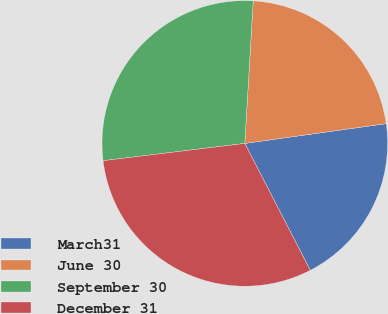Convert chart to OTSL. <chart><loc_0><loc_0><loc_500><loc_500><pie_chart><fcel>March31<fcel>June 30<fcel>September 30<fcel>December 31<nl><fcel>19.63%<fcel>21.85%<fcel>27.87%<fcel>30.65%<nl></chart> 